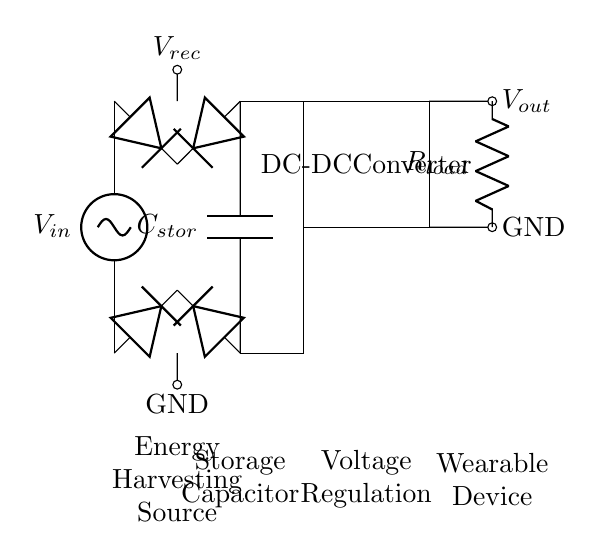What is the load resistance in the circuit? The load resistance is labeled as R load in the circuit diagram, indicating it is connected to the output.
Answer: R load What component stores energy in this circuit? The component responsible for storing energy is labeled as C stor in the diagram, indicating it's a storage capacitor.
Answer: C stor What type of voltage source is used? The voltage source is a sine wave voltage source, identified as V in in the circuit, showcasing that it provides alternating current.
Answer: V in What is the purpose of the diodes in this circuit? The diodes in this circuit function as a rectifier, allowing current to flow in one direction only, which is essential for converting AC to DC for the storage capacitor.
Answer: Rectification How is the output voltage regulated in this circuit? The circuit includes a DC-DC converter, visually represented as a rectangle, which regulates the output voltage by adjusting it to the necessary level for the wearable device.
Answer: DC-DC converter Why is a capacitor used for energy storage here? A capacitor is used for energy storage because it can quickly charge and discharge, making it suitable for powering devices with intermittent energy input, like wearable devices harvesting energy.
Answer: Quick charge and discharge What is the role of the voltage source in this energy harvesting circuit? The voltage source is crucial as it provides the initial energy input needed for the circuit to operate, which is subsequently transformed into usable energy for the wearable device.
Answer: Initial energy input 